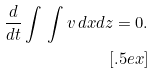<formula> <loc_0><loc_0><loc_500><loc_500>\frac { d } { d t } \int \, \int v \, d x d z = 0 . \\ [ . 5 e x ]</formula> 